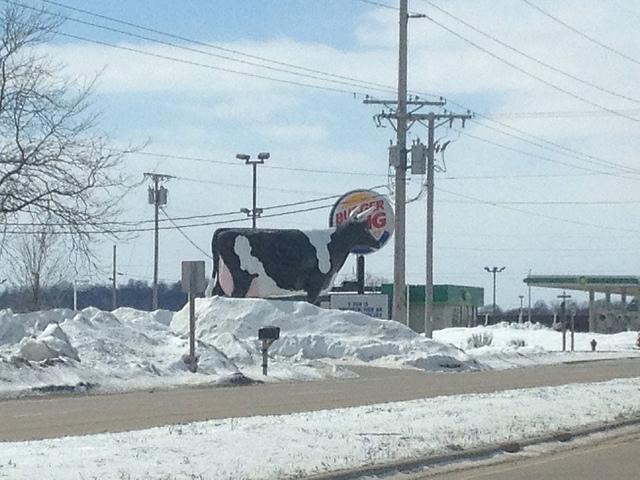What fast food chain is visible?
Quick response, please. Burger king. Which season is happening in this place?
Answer briefly. Winter. What is on top of the snow?
Keep it brief. Cow. 